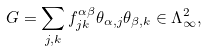<formula> <loc_0><loc_0><loc_500><loc_500>G = \sum _ { j , k } f ^ { \alpha \beta } _ { j k } \theta _ { \alpha , j } \theta _ { \beta , k } \in \Lambda ^ { 2 } _ { \infty } ,</formula> 